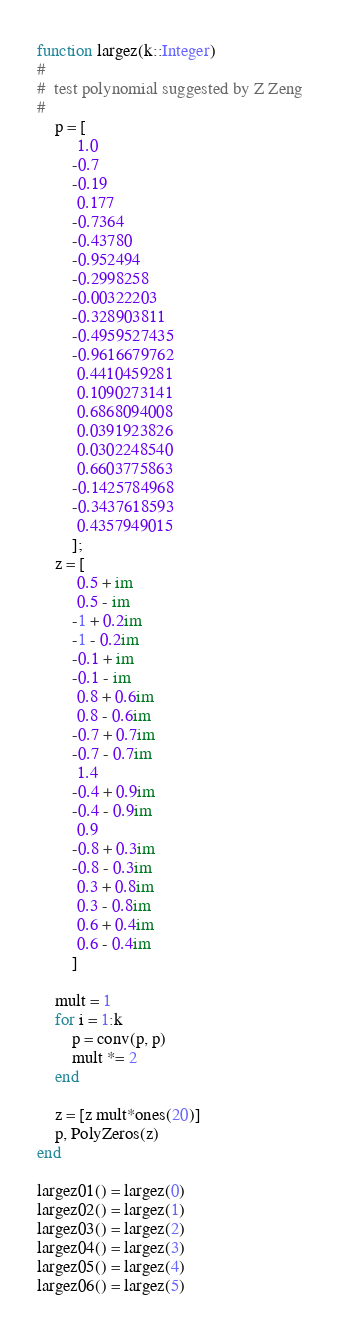Convert code to text. <code><loc_0><loc_0><loc_500><loc_500><_Julia_>function largez(k::Integer)
#
#  test polynomial suggested by Z Zeng
#
    p = [ 
         1.0
        -0.7
        -0.19
         0.177
        -0.7364
        -0.43780
        -0.952494
        -0.2998258
        -0.00322203
        -0.328903811
        -0.4959527435
        -0.9616679762
         0.4410459281
         0.1090273141
         0.6868094008
         0.0391923826
         0.0302248540
         0.6603775863
        -0.1425784968
        -0.3437618593
         0.4357949015
        ];
    z = [
         0.5 + im
         0.5 - im
        -1 + 0.2im
        -1 - 0.2im
        -0.1 + im
        -0.1 - im
         0.8 + 0.6im
         0.8 - 0.6im
        -0.7 + 0.7im
        -0.7 - 0.7im
         1.4
        -0.4 + 0.9im
        -0.4 - 0.9im
         0.9
        -0.8 + 0.3im
        -0.8 - 0.3im
         0.3 + 0.8im
         0.3 - 0.8im
         0.6 + 0.4im
         0.6 - 0.4im
        ]
    
    mult = 1
    for i = 1:k
        p = conv(p, p)
        mult *= 2
    end

    z = [z mult*ones(20)]
    p, PolyZeros(z)
end

largez01() = largez(0)
largez02() = largez(1)
largez03() = largez(2)
largez04() = largez(3)
largez05() = largez(4)
largez06() = largez(5)

</code> 